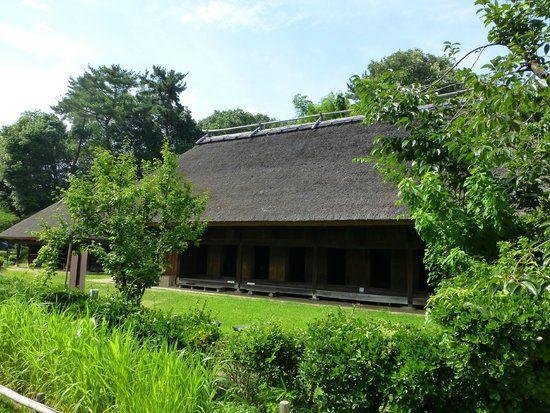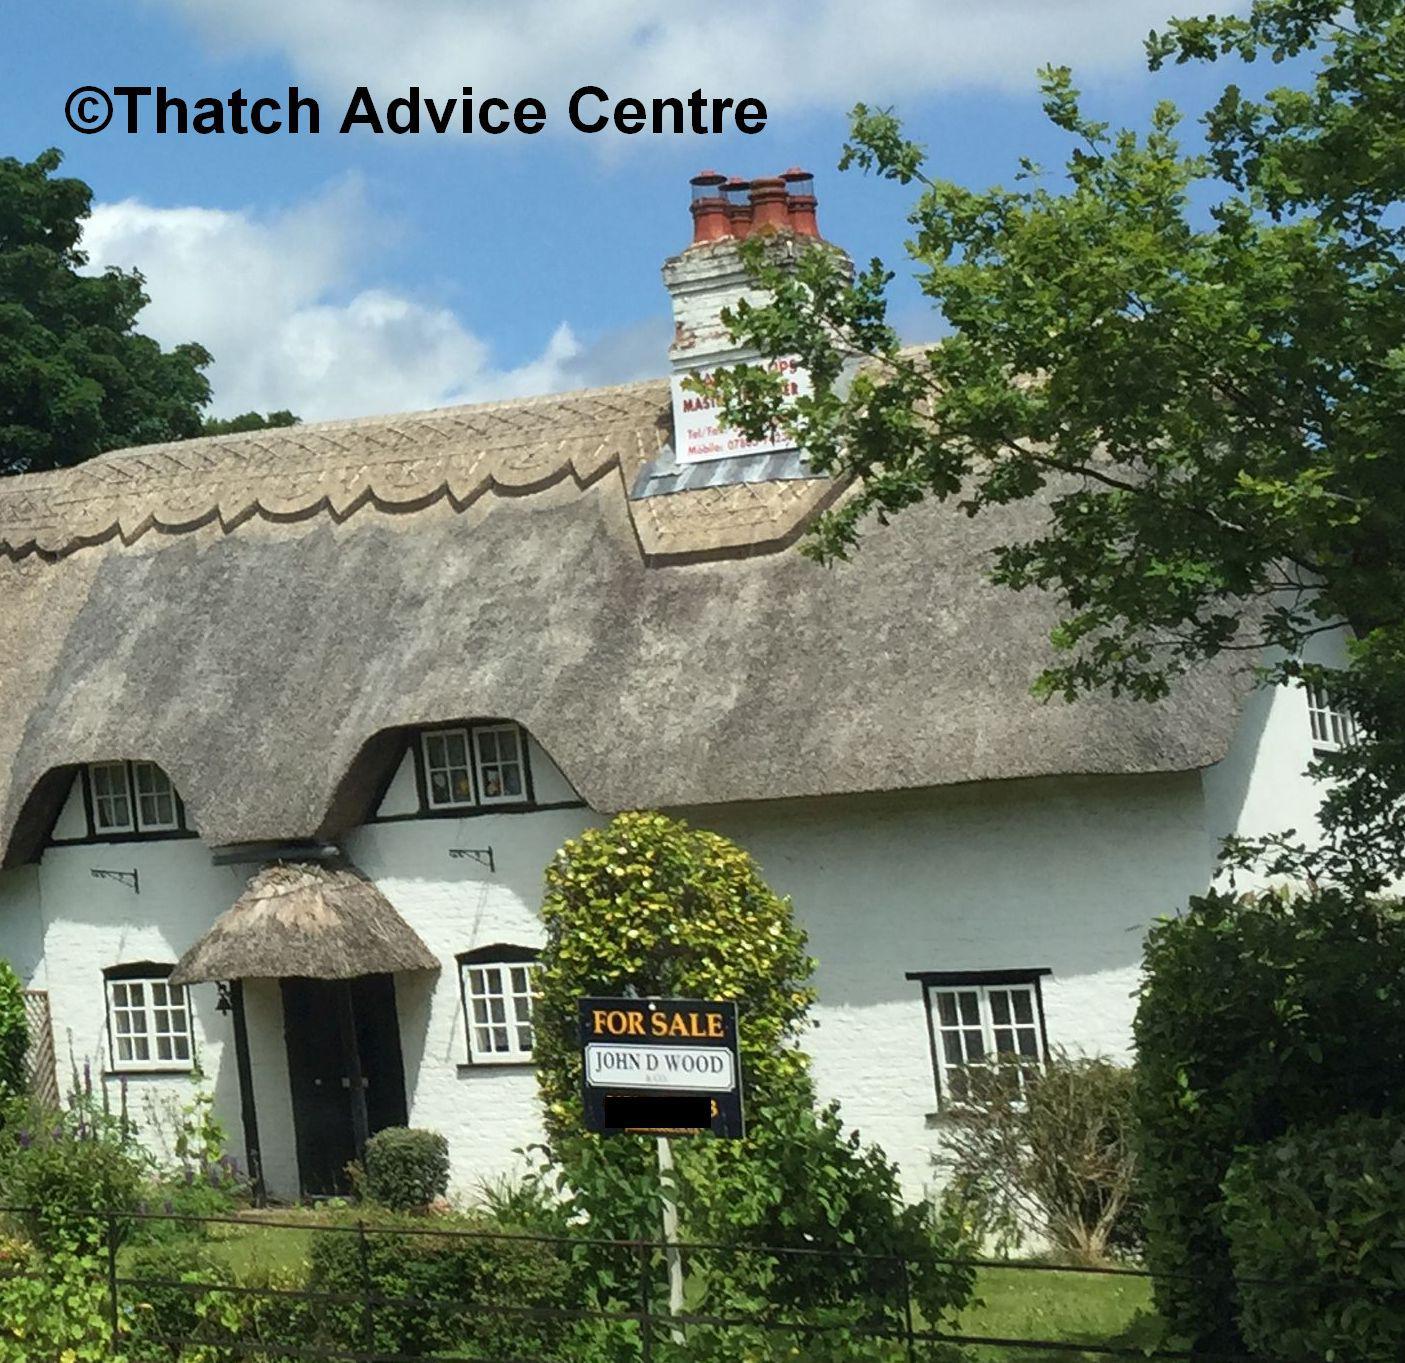The first image is the image on the left, the second image is the image on the right. For the images shown, is this caption "The right image shows the front of a pale stucco-look house with a scalloped border on the peak of the roof and with two notches in the roof's bottom edge to accommodate windows." true? Answer yes or no. Yes. The first image is the image on the left, the second image is the image on the right. Evaluate the accuracy of this statement regarding the images: "The thatching on the house in the image to the right, is a dark gray.". Is it true? Answer yes or no. No. 